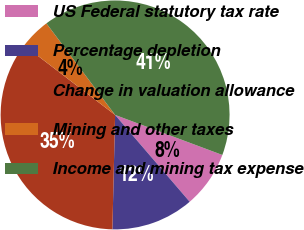Convert chart to OTSL. <chart><loc_0><loc_0><loc_500><loc_500><pie_chart><fcel>US Federal statutory tax rate<fcel>Percentage depletion<fcel>Change in valuation allowance<fcel>Mining and other taxes<fcel>Income and mining tax expense<nl><fcel>8.02%<fcel>11.67%<fcel>35.02%<fcel>4.36%<fcel>40.93%<nl></chart> 